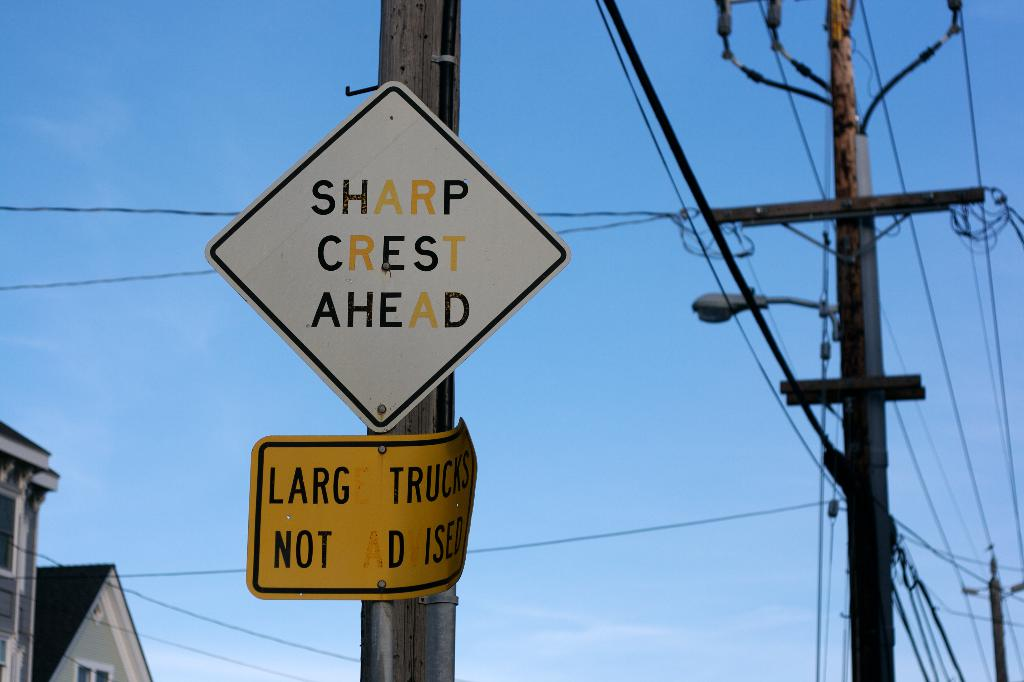Could the time of day and weather conditions affect the relevance of these signs? Yes, during nighttime or adverse weather conditions such as fog or heavy rain, visibility decreases, making these signs even more crucial for alerting drivers about upcoming road conditions. Well-placed signs help in precautionary measures to prevent accidents under such circumstances. 